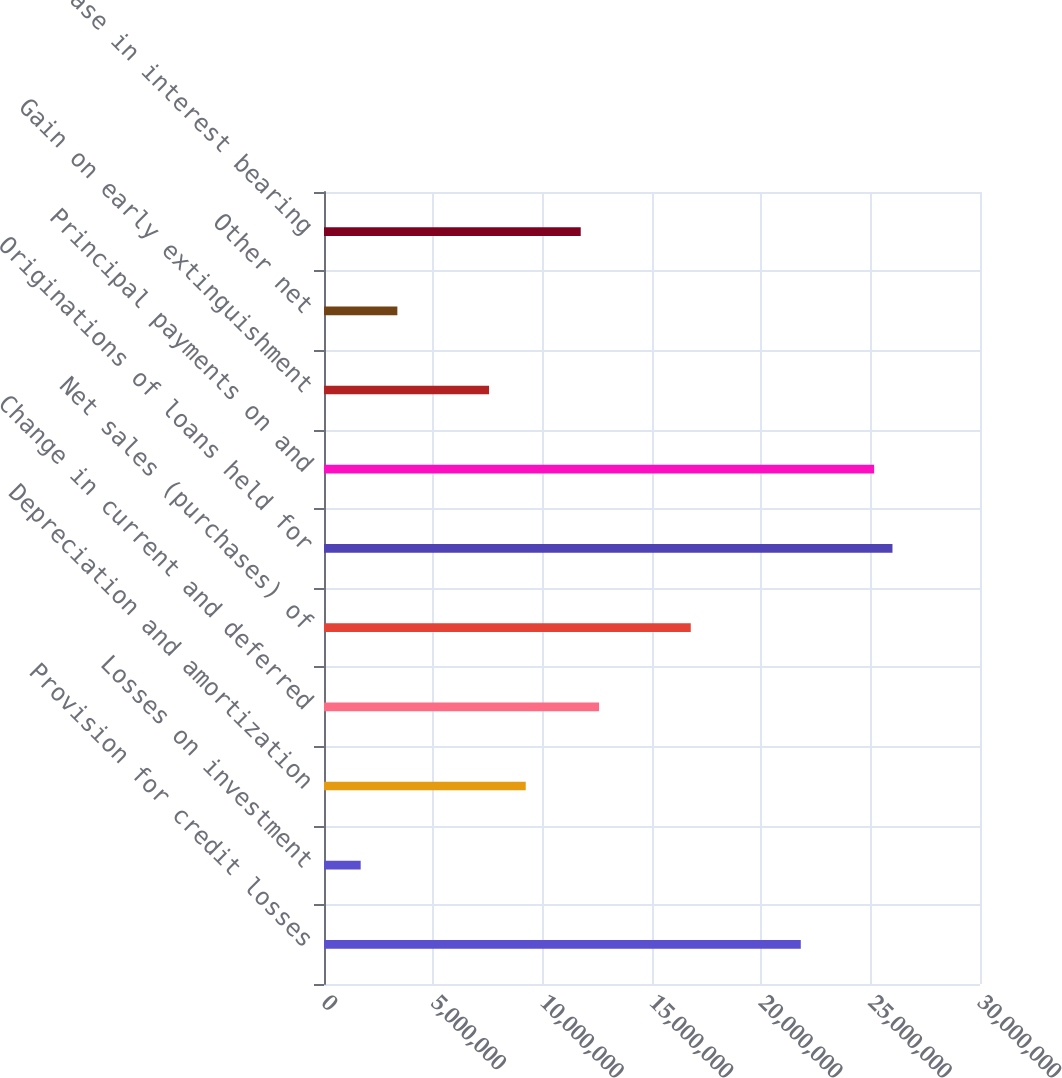Convert chart to OTSL. <chart><loc_0><loc_0><loc_500><loc_500><bar_chart><fcel>Provision for credit losses<fcel>Losses on investment<fcel>Depreciation and amortization<fcel>Change in current and deferred<fcel>Net sales (purchases) of<fcel>Originations of loans held for<fcel>Principal payments on and<fcel>Gain on early extinguishment<fcel>Other net<fcel>Increase in interest bearing<nl><fcel>2.1804e+07<fcel>1.67734e+06<fcel>9.22483e+06<fcel>1.25793e+07<fcel>1.67723e+07<fcel>2.5997e+07<fcel>2.51584e+07<fcel>7.54761e+06<fcel>3.35456e+06<fcel>1.17407e+07<nl></chart> 